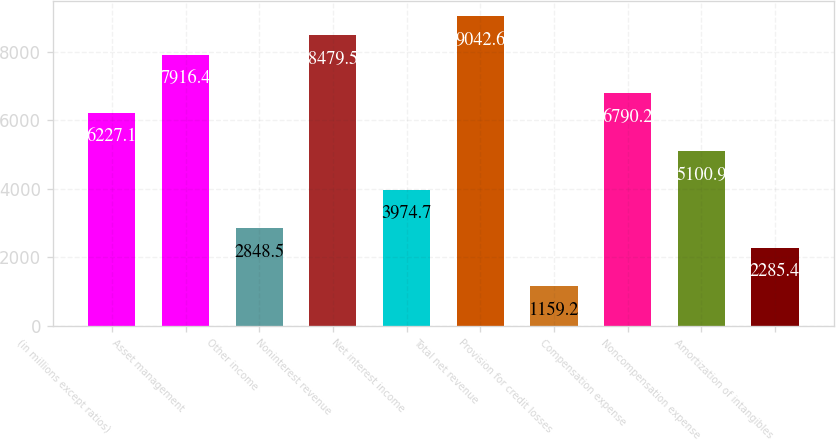<chart> <loc_0><loc_0><loc_500><loc_500><bar_chart><fcel>(in millions except ratios)<fcel>Asset management<fcel>Other income<fcel>Noninterest revenue<fcel>Net interest income<fcel>Total net revenue<fcel>Provision for credit losses<fcel>Compensation expense<fcel>Noncompensation expense<fcel>Amortization of intangibles<nl><fcel>6227.1<fcel>7916.4<fcel>2848.5<fcel>8479.5<fcel>3974.7<fcel>9042.6<fcel>1159.2<fcel>6790.2<fcel>5100.9<fcel>2285.4<nl></chart> 